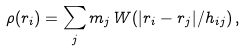Convert formula to latex. <formula><loc_0><loc_0><loc_500><loc_500>\rho ( r _ { i } ) = \sum _ { j } m _ { j } \, W ( | r _ { i } - r _ { j } | / h _ { i j } ) \, ,</formula> 